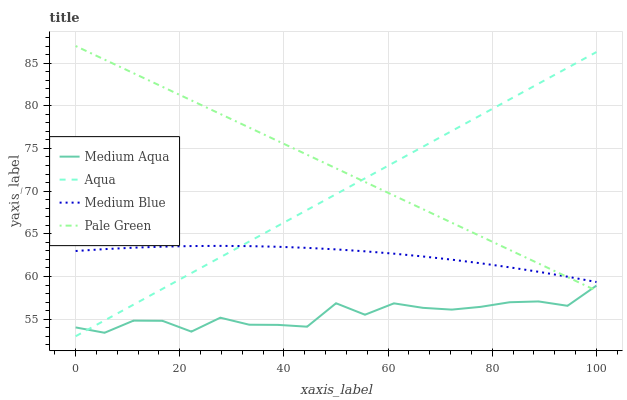Does Medium Aqua have the minimum area under the curve?
Answer yes or no. Yes. Does Pale Green have the maximum area under the curve?
Answer yes or no. Yes. Does Pale Green have the minimum area under the curve?
Answer yes or no. No. Does Medium Aqua have the maximum area under the curve?
Answer yes or no. No. Is Aqua the smoothest?
Answer yes or no. Yes. Is Medium Aqua the roughest?
Answer yes or no. Yes. Is Pale Green the smoothest?
Answer yes or no. No. Is Pale Green the roughest?
Answer yes or no. No. Does Aqua have the lowest value?
Answer yes or no. Yes. Does Pale Green have the lowest value?
Answer yes or no. No. Does Pale Green have the highest value?
Answer yes or no. Yes. Does Medium Aqua have the highest value?
Answer yes or no. No. Is Medium Aqua less than Medium Blue?
Answer yes or no. Yes. Is Medium Blue greater than Medium Aqua?
Answer yes or no. Yes. Does Aqua intersect Medium Blue?
Answer yes or no. Yes. Is Aqua less than Medium Blue?
Answer yes or no. No. Is Aqua greater than Medium Blue?
Answer yes or no. No. Does Medium Aqua intersect Medium Blue?
Answer yes or no. No. 